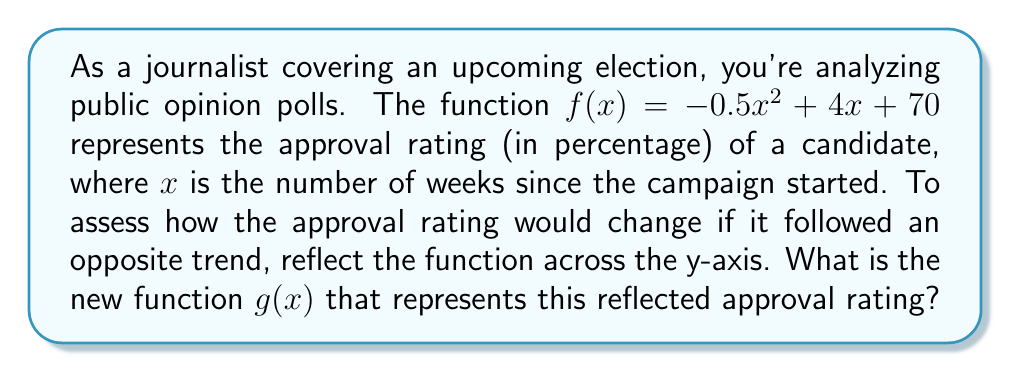Could you help me with this problem? To reflect a function across the y-axis, we need to replace every $x$ in the original function with $-x$. This process can be broken down into steps:

1. Start with the original function: $f(x) = -0.5x^2 + 4x + 70$

2. Replace every $x$ with $-x$:
   $g(x) = -0.5(-x)^2 + 4(-x) + 70$

3. Simplify:
   - $(-x)^2 = x^2$ (because a negative squared becomes positive)
   - $4(-x) = -4x$

   So, $g(x) = -0.5x^2 - 4x + 70$

4. The final reflected function is:
   $g(x) = -0.5x^2 - 4x + 70$

This reflection changes the linear term from positive to negative, effectively "flipping" the parabola horizontally while keeping its vertex on the y-axis.
Answer: $g(x) = -0.5x^2 - 4x + 70$ 